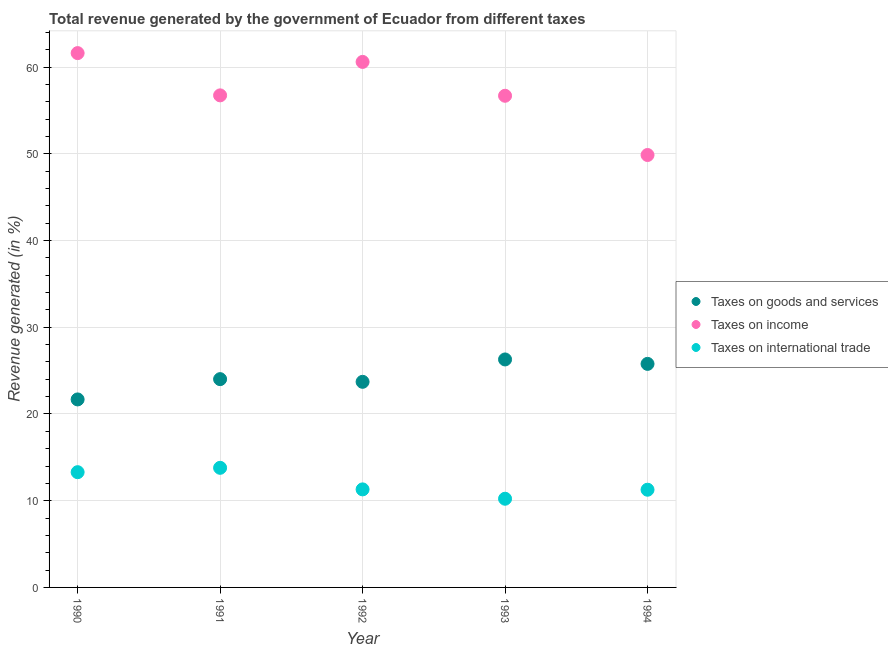How many different coloured dotlines are there?
Keep it short and to the point. 3. What is the percentage of revenue generated by taxes on income in 1991?
Provide a short and direct response. 56.74. Across all years, what is the maximum percentage of revenue generated by taxes on income?
Keep it short and to the point. 61.61. Across all years, what is the minimum percentage of revenue generated by taxes on goods and services?
Your answer should be very brief. 21.68. What is the total percentage of revenue generated by tax on international trade in the graph?
Give a very brief answer. 59.88. What is the difference between the percentage of revenue generated by tax on international trade in 1992 and that in 1994?
Offer a very short reply. 0.04. What is the difference between the percentage of revenue generated by tax on international trade in 1994 and the percentage of revenue generated by taxes on income in 1990?
Offer a very short reply. -50.34. What is the average percentage of revenue generated by taxes on income per year?
Offer a terse response. 57.1. In the year 1993, what is the difference between the percentage of revenue generated by taxes on goods and services and percentage of revenue generated by tax on international trade?
Your response must be concise. 16.06. What is the ratio of the percentage of revenue generated by taxes on income in 1991 to that in 1992?
Offer a terse response. 0.94. Is the percentage of revenue generated by tax on international trade in 1990 less than that in 1992?
Your response must be concise. No. Is the difference between the percentage of revenue generated by tax on international trade in 1992 and 1993 greater than the difference between the percentage of revenue generated by taxes on goods and services in 1992 and 1993?
Provide a succinct answer. Yes. What is the difference between the highest and the second highest percentage of revenue generated by tax on international trade?
Offer a terse response. 0.5. What is the difference between the highest and the lowest percentage of revenue generated by taxes on income?
Your answer should be very brief. 11.75. In how many years, is the percentage of revenue generated by taxes on income greater than the average percentage of revenue generated by taxes on income taken over all years?
Offer a very short reply. 2. Is it the case that in every year, the sum of the percentage of revenue generated by taxes on goods and services and percentage of revenue generated by taxes on income is greater than the percentage of revenue generated by tax on international trade?
Make the answer very short. Yes. Does the percentage of revenue generated by taxes on goods and services monotonically increase over the years?
Your answer should be compact. No. Is the percentage of revenue generated by taxes on income strictly greater than the percentage of revenue generated by taxes on goods and services over the years?
Provide a succinct answer. Yes. How many dotlines are there?
Keep it short and to the point. 3. Are the values on the major ticks of Y-axis written in scientific E-notation?
Provide a succinct answer. No. Where does the legend appear in the graph?
Your response must be concise. Center right. How many legend labels are there?
Offer a terse response. 3. How are the legend labels stacked?
Make the answer very short. Vertical. What is the title of the graph?
Offer a very short reply. Total revenue generated by the government of Ecuador from different taxes. What is the label or title of the Y-axis?
Make the answer very short. Revenue generated (in %). What is the Revenue generated (in %) in Taxes on goods and services in 1990?
Your answer should be very brief. 21.68. What is the Revenue generated (in %) of Taxes on income in 1990?
Give a very brief answer. 61.61. What is the Revenue generated (in %) of Taxes on international trade in 1990?
Ensure brevity in your answer.  13.29. What is the Revenue generated (in %) of Taxes on goods and services in 1991?
Your answer should be compact. 24.02. What is the Revenue generated (in %) of Taxes on income in 1991?
Keep it short and to the point. 56.74. What is the Revenue generated (in %) in Taxes on international trade in 1991?
Your answer should be very brief. 13.79. What is the Revenue generated (in %) of Taxes on goods and services in 1992?
Provide a succinct answer. 23.71. What is the Revenue generated (in %) of Taxes on income in 1992?
Your answer should be compact. 60.59. What is the Revenue generated (in %) of Taxes on international trade in 1992?
Provide a succinct answer. 11.3. What is the Revenue generated (in %) of Taxes on goods and services in 1993?
Offer a terse response. 26.29. What is the Revenue generated (in %) in Taxes on income in 1993?
Offer a very short reply. 56.69. What is the Revenue generated (in %) of Taxes on international trade in 1993?
Ensure brevity in your answer.  10.23. What is the Revenue generated (in %) of Taxes on goods and services in 1994?
Keep it short and to the point. 25.78. What is the Revenue generated (in %) of Taxes on income in 1994?
Ensure brevity in your answer.  49.86. What is the Revenue generated (in %) in Taxes on international trade in 1994?
Make the answer very short. 11.27. Across all years, what is the maximum Revenue generated (in %) in Taxes on goods and services?
Give a very brief answer. 26.29. Across all years, what is the maximum Revenue generated (in %) in Taxes on income?
Offer a terse response. 61.61. Across all years, what is the maximum Revenue generated (in %) of Taxes on international trade?
Ensure brevity in your answer.  13.79. Across all years, what is the minimum Revenue generated (in %) in Taxes on goods and services?
Keep it short and to the point. 21.68. Across all years, what is the minimum Revenue generated (in %) of Taxes on income?
Ensure brevity in your answer.  49.86. Across all years, what is the minimum Revenue generated (in %) of Taxes on international trade?
Ensure brevity in your answer.  10.23. What is the total Revenue generated (in %) of Taxes on goods and services in the graph?
Offer a very short reply. 121.47. What is the total Revenue generated (in %) in Taxes on income in the graph?
Keep it short and to the point. 285.5. What is the total Revenue generated (in %) of Taxes on international trade in the graph?
Your answer should be compact. 59.88. What is the difference between the Revenue generated (in %) of Taxes on goods and services in 1990 and that in 1991?
Your answer should be very brief. -2.34. What is the difference between the Revenue generated (in %) of Taxes on income in 1990 and that in 1991?
Give a very brief answer. 4.87. What is the difference between the Revenue generated (in %) of Taxes on international trade in 1990 and that in 1991?
Offer a very short reply. -0.5. What is the difference between the Revenue generated (in %) of Taxes on goods and services in 1990 and that in 1992?
Your answer should be very brief. -2.03. What is the difference between the Revenue generated (in %) of Taxes on income in 1990 and that in 1992?
Ensure brevity in your answer.  1.02. What is the difference between the Revenue generated (in %) of Taxes on international trade in 1990 and that in 1992?
Offer a very short reply. 1.98. What is the difference between the Revenue generated (in %) of Taxes on goods and services in 1990 and that in 1993?
Make the answer very short. -4.61. What is the difference between the Revenue generated (in %) of Taxes on income in 1990 and that in 1993?
Your response must be concise. 4.92. What is the difference between the Revenue generated (in %) of Taxes on international trade in 1990 and that in 1993?
Provide a succinct answer. 3.06. What is the difference between the Revenue generated (in %) in Taxes on goods and services in 1990 and that in 1994?
Ensure brevity in your answer.  -4.1. What is the difference between the Revenue generated (in %) of Taxes on income in 1990 and that in 1994?
Your answer should be compact. 11.75. What is the difference between the Revenue generated (in %) in Taxes on international trade in 1990 and that in 1994?
Give a very brief answer. 2.02. What is the difference between the Revenue generated (in %) of Taxes on goods and services in 1991 and that in 1992?
Give a very brief answer. 0.31. What is the difference between the Revenue generated (in %) in Taxes on income in 1991 and that in 1992?
Make the answer very short. -3.86. What is the difference between the Revenue generated (in %) in Taxes on international trade in 1991 and that in 1992?
Your response must be concise. 2.49. What is the difference between the Revenue generated (in %) in Taxes on goods and services in 1991 and that in 1993?
Offer a very short reply. -2.27. What is the difference between the Revenue generated (in %) of Taxes on income in 1991 and that in 1993?
Your answer should be very brief. 0.05. What is the difference between the Revenue generated (in %) in Taxes on international trade in 1991 and that in 1993?
Provide a short and direct response. 3.56. What is the difference between the Revenue generated (in %) in Taxes on goods and services in 1991 and that in 1994?
Offer a terse response. -1.76. What is the difference between the Revenue generated (in %) of Taxes on income in 1991 and that in 1994?
Ensure brevity in your answer.  6.88. What is the difference between the Revenue generated (in %) of Taxes on international trade in 1991 and that in 1994?
Make the answer very short. 2.53. What is the difference between the Revenue generated (in %) in Taxes on goods and services in 1992 and that in 1993?
Provide a short and direct response. -2.58. What is the difference between the Revenue generated (in %) in Taxes on income in 1992 and that in 1993?
Ensure brevity in your answer.  3.9. What is the difference between the Revenue generated (in %) in Taxes on international trade in 1992 and that in 1993?
Ensure brevity in your answer.  1.08. What is the difference between the Revenue generated (in %) of Taxes on goods and services in 1992 and that in 1994?
Provide a succinct answer. -2.07. What is the difference between the Revenue generated (in %) in Taxes on income in 1992 and that in 1994?
Give a very brief answer. 10.73. What is the difference between the Revenue generated (in %) of Taxes on international trade in 1992 and that in 1994?
Ensure brevity in your answer.  0.04. What is the difference between the Revenue generated (in %) in Taxes on goods and services in 1993 and that in 1994?
Provide a succinct answer. 0.51. What is the difference between the Revenue generated (in %) in Taxes on income in 1993 and that in 1994?
Give a very brief answer. 6.83. What is the difference between the Revenue generated (in %) in Taxes on international trade in 1993 and that in 1994?
Offer a very short reply. -1.04. What is the difference between the Revenue generated (in %) in Taxes on goods and services in 1990 and the Revenue generated (in %) in Taxes on income in 1991?
Make the answer very short. -35.06. What is the difference between the Revenue generated (in %) in Taxes on goods and services in 1990 and the Revenue generated (in %) in Taxes on international trade in 1991?
Make the answer very short. 7.89. What is the difference between the Revenue generated (in %) of Taxes on income in 1990 and the Revenue generated (in %) of Taxes on international trade in 1991?
Ensure brevity in your answer.  47.82. What is the difference between the Revenue generated (in %) of Taxes on goods and services in 1990 and the Revenue generated (in %) of Taxes on income in 1992?
Ensure brevity in your answer.  -38.92. What is the difference between the Revenue generated (in %) in Taxes on goods and services in 1990 and the Revenue generated (in %) in Taxes on international trade in 1992?
Your response must be concise. 10.37. What is the difference between the Revenue generated (in %) in Taxes on income in 1990 and the Revenue generated (in %) in Taxes on international trade in 1992?
Keep it short and to the point. 50.31. What is the difference between the Revenue generated (in %) in Taxes on goods and services in 1990 and the Revenue generated (in %) in Taxes on income in 1993?
Ensure brevity in your answer.  -35.01. What is the difference between the Revenue generated (in %) in Taxes on goods and services in 1990 and the Revenue generated (in %) in Taxes on international trade in 1993?
Offer a very short reply. 11.45. What is the difference between the Revenue generated (in %) of Taxes on income in 1990 and the Revenue generated (in %) of Taxes on international trade in 1993?
Give a very brief answer. 51.38. What is the difference between the Revenue generated (in %) in Taxes on goods and services in 1990 and the Revenue generated (in %) in Taxes on income in 1994?
Your answer should be very brief. -28.18. What is the difference between the Revenue generated (in %) of Taxes on goods and services in 1990 and the Revenue generated (in %) of Taxes on international trade in 1994?
Your response must be concise. 10.41. What is the difference between the Revenue generated (in %) in Taxes on income in 1990 and the Revenue generated (in %) in Taxes on international trade in 1994?
Make the answer very short. 50.34. What is the difference between the Revenue generated (in %) in Taxes on goods and services in 1991 and the Revenue generated (in %) in Taxes on income in 1992?
Provide a short and direct response. -36.58. What is the difference between the Revenue generated (in %) in Taxes on goods and services in 1991 and the Revenue generated (in %) in Taxes on international trade in 1992?
Provide a short and direct response. 12.71. What is the difference between the Revenue generated (in %) in Taxes on income in 1991 and the Revenue generated (in %) in Taxes on international trade in 1992?
Ensure brevity in your answer.  45.43. What is the difference between the Revenue generated (in %) in Taxes on goods and services in 1991 and the Revenue generated (in %) in Taxes on income in 1993?
Ensure brevity in your answer.  -32.68. What is the difference between the Revenue generated (in %) in Taxes on goods and services in 1991 and the Revenue generated (in %) in Taxes on international trade in 1993?
Provide a succinct answer. 13.79. What is the difference between the Revenue generated (in %) of Taxes on income in 1991 and the Revenue generated (in %) of Taxes on international trade in 1993?
Offer a very short reply. 46.51. What is the difference between the Revenue generated (in %) in Taxes on goods and services in 1991 and the Revenue generated (in %) in Taxes on income in 1994?
Keep it short and to the point. -25.84. What is the difference between the Revenue generated (in %) in Taxes on goods and services in 1991 and the Revenue generated (in %) in Taxes on international trade in 1994?
Your answer should be very brief. 12.75. What is the difference between the Revenue generated (in %) of Taxes on income in 1991 and the Revenue generated (in %) of Taxes on international trade in 1994?
Offer a very short reply. 45.47. What is the difference between the Revenue generated (in %) of Taxes on goods and services in 1992 and the Revenue generated (in %) of Taxes on income in 1993?
Your response must be concise. -32.98. What is the difference between the Revenue generated (in %) in Taxes on goods and services in 1992 and the Revenue generated (in %) in Taxes on international trade in 1993?
Make the answer very short. 13.48. What is the difference between the Revenue generated (in %) in Taxes on income in 1992 and the Revenue generated (in %) in Taxes on international trade in 1993?
Ensure brevity in your answer.  50.37. What is the difference between the Revenue generated (in %) in Taxes on goods and services in 1992 and the Revenue generated (in %) in Taxes on income in 1994?
Provide a short and direct response. -26.15. What is the difference between the Revenue generated (in %) of Taxes on goods and services in 1992 and the Revenue generated (in %) of Taxes on international trade in 1994?
Your answer should be compact. 12.44. What is the difference between the Revenue generated (in %) of Taxes on income in 1992 and the Revenue generated (in %) of Taxes on international trade in 1994?
Give a very brief answer. 49.33. What is the difference between the Revenue generated (in %) in Taxes on goods and services in 1993 and the Revenue generated (in %) in Taxes on income in 1994?
Offer a very short reply. -23.57. What is the difference between the Revenue generated (in %) in Taxes on goods and services in 1993 and the Revenue generated (in %) in Taxes on international trade in 1994?
Provide a succinct answer. 15.02. What is the difference between the Revenue generated (in %) of Taxes on income in 1993 and the Revenue generated (in %) of Taxes on international trade in 1994?
Keep it short and to the point. 45.43. What is the average Revenue generated (in %) of Taxes on goods and services per year?
Your answer should be very brief. 24.29. What is the average Revenue generated (in %) of Taxes on income per year?
Provide a short and direct response. 57.1. What is the average Revenue generated (in %) in Taxes on international trade per year?
Provide a short and direct response. 11.98. In the year 1990, what is the difference between the Revenue generated (in %) of Taxes on goods and services and Revenue generated (in %) of Taxes on income?
Provide a short and direct response. -39.93. In the year 1990, what is the difference between the Revenue generated (in %) in Taxes on goods and services and Revenue generated (in %) in Taxes on international trade?
Offer a terse response. 8.39. In the year 1990, what is the difference between the Revenue generated (in %) of Taxes on income and Revenue generated (in %) of Taxes on international trade?
Make the answer very short. 48.32. In the year 1991, what is the difference between the Revenue generated (in %) of Taxes on goods and services and Revenue generated (in %) of Taxes on income?
Your response must be concise. -32.72. In the year 1991, what is the difference between the Revenue generated (in %) of Taxes on goods and services and Revenue generated (in %) of Taxes on international trade?
Your answer should be very brief. 10.23. In the year 1991, what is the difference between the Revenue generated (in %) of Taxes on income and Revenue generated (in %) of Taxes on international trade?
Your answer should be very brief. 42.95. In the year 1992, what is the difference between the Revenue generated (in %) of Taxes on goods and services and Revenue generated (in %) of Taxes on income?
Provide a succinct answer. -36.89. In the year 1992, what is the difference between the Revenue generated (in %) of Taxes on goods and services and Revenue generated (in %) of Taxes on international trade?
Give a very brief answer. 12.4. In the year 1992, what is the difference between the Revenue generated (in %) of Taxes on income and Revenue generated (in %) of Taxes on international trade?
Keep it short and to the point. 49.29. In the year 1993, what is the difference between the Revenue generated (in %) of Taxes on goods and services and Revenue generated (in %) of Taxes on income?
Keep it short and to the point. -30.4. In the year 1993, what is the difference between the Revenue generated (in %) of Taxes on goods and services and Revenue generated (in %) of Taxes on international trade?
Your answer should be very brief. 16.06. In the year 1993, what is the difference between the Revenue generated (in %) in Taxes on income and Revenue generated (in %) in Taxes on international trade?
Keep it short and to the point. 46.47. In the year 1994, what is the difference between the Revenue generated (in %) in Taxes on goods and services and Revenue generated (in %) in Taxes on income?
Provide a succinct answer. -24.08. In the year 1994, what is the difference between the Revenue generated (in %) in Taxes on goods and services and Revenue generated (in %) in Taxes on international trade?
Provide a short and direct response. 14.51. In the year 1994, what is the difference between the Revenue generated (in %) of Taxes on income and Revenue generated (in %) of Taxes on international trade?
Give a very brief answer. 38.59. What is the ratio of the Revenue generated (in %) of Taxes on goods and services in 1990 to that in 1991?
Provide a short and direct response. 0.9. What is the ratio of the Revenue generated (in %) of Taxes on income in 1990 to that in 1991?
Offer a very short reply. 1.09. What is the ratio of the Revenue generated (in %) in Taxes on international trade in 1990 to that in 1991?
Keep it short and to the point. 0.96. What is the ratio of the Revenue generated (in %) in Taxes on goods and services in 1990 to that in 1992?
Ensure brevity in your answer.  0.91. What is the ratio of the Revenue generated (in %) in Taxes on income in 1990 to that in 1992?
Keep it short and to the point. 1.02. What is the ratio of the Revenue generated (in %) of Taxes on international trade in 1990 to that in 1992?
Make the answer very short. 1.18. What is the ratio of the Revenue generated (in %) of Taxes on goods and services in 1990 to that in 1993?
Offer a terse response. 0.82. What is the ratio of the Revenue generated (in %) in Taxes on income in 1990 to that in 1993?
Your answer should be compact. 1.09. What is the ratio of the Revenue generated (in %) of Taxes on international trade in 1990 to that in 1993?
Your answer should be very brief. 1.3. What is the ratio of the Revenue generated (in %) of Taxes on goods and services in 1990 to that in 1994?
Your response must be concise. 0.84. What is the ratio of the Revenue generated (in %) in Taxes on income in 1990 to that in 1994?
Provide a succinct answer. 1.24. What is the ratio of the Revenue generated (in %) in Taxes on international trade in 1990 to that in 1994?
Provide a succinct answer. 1.18. What is the ratio of the Revenue generated (in %) of Taxes on goods and services in 1991 to that in 1992?
Your answer should be very brief. 1.01. What is the ratio of the Revenue generated (in %) of Taxes on income in 1991 to that in 1992?
Keep it short and to the point. 0.94. What is the ratio of the Revenue generated (in %) of Taxes on international trade in 1991 to that in 1992?
Provide a succinct answer. 1.22. What is the ratio of the Revenue generated (in %) in Taxes on goods and services in 1991 to that in 1993?
Your answer should be very brief. 0.91. What is the ratio of the Revenue generated (in %) of Taxes on international trade in 1991 to that in 1993?
Give a very brief answer. 1.35. What is the ratio of the Revenue generated (in %) in Taxes on goods and services in 1991 to that in 1994?
Offer a very short reply. 0.93. What is the ratio of the Revenue generated (in %) of Taxes on income in 1991 to that in 1994?
Offer a very short reply. 1.14. What is the ratio of the Revenue generated (in %) in Taxes on international trade in 1991 to that in 1994?
Offer a terse response. 1.22. What is the ratio of the Revenue generated (in %) in Taxes on goods and services in 1992 to that in 1993?
Offer a very short reply. 0.9. What is the ratio of the Revenue generated (in %) in Taxes on income in 1992 to that in 1993?
Offer a very short reply. 1.07. What is the ratio of the Revenue generated (in %) of Taxes on international trade in 1992 to that in 1993?
Your answer should be very brief. 1.11. What is the ratio of the Revenue generated (in %) in Taxes on goods and services in 1992 to that in 1994?
Your answer should be compact. 0.92. What is the ratio of the Revenue generated (in %) in Taxes on income in 1992 to that in 1994?
Your response must be concise. 1.22. What is the ratio of the Revenue generated (in %) in Taxes on international trade in 1992 to that in 1994?
Give a very brief answer. 1. What is the ratio of the Revenue generated (in %) in Taxes on goods and services in 1993 to that in 1994?
Provide a short and direct response. 1.02. What is the ratio of the Revenue generated (in %) of Taxes on income in 1993 to that in 1994?
Offer a very short reply. 1.14. What is the ratio of the Revenue generated (in %) of Taxes on international trade in 1993 to that in 1994?
Your answer should be compact. 0.91. What is the difference between the highest and the second highest Revenue generated (in %) of Taxes on goods and services?
Make the answer very short. 0.51. What is the difference between the highest and the second highest Revenue generated (in %) in Taxes on income?
Provide a short and direct response. 1.02. What is the difference between the highest and the second highest Revenue generated (in %) in Taxes on international trade?
Provide a short and direct response. 0.5. What is the difference between the highest and the lowest Revenue generated (in %) of Taxes on goods and services?
Offer a terse response. 4.61. What is the difference between the highest and the lowest Revenue generated (in %) of Taxes on income?
Keep it short and to the point. 11.75. What is the difference between the highest and the lowest Revenue generated (in %) of Taxes on international trade?
Offer a terse response. 3.56. 